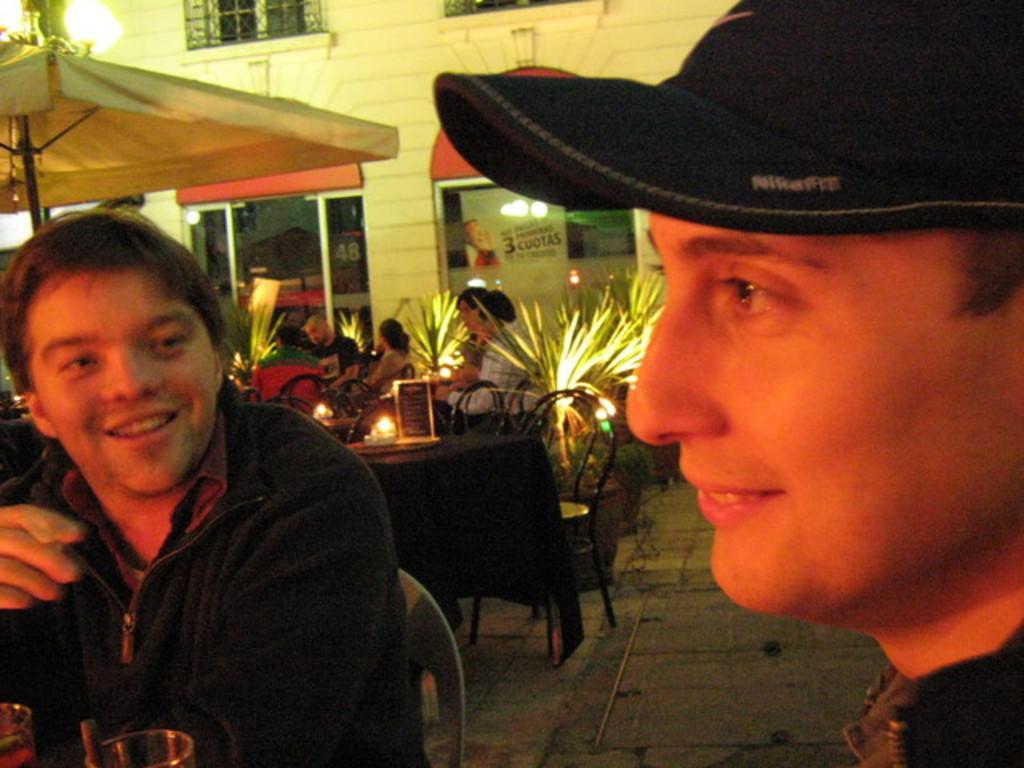Please provide a concise description of this image. In this picture there is a building and there is an umbrella and there are tables and chairs and there are objects on the tables. In the foreground there are two people sitting and smiling and there are glasses. At the back there is a poster on the mirror and there is text on the poster. At the bottom there is a floor. 